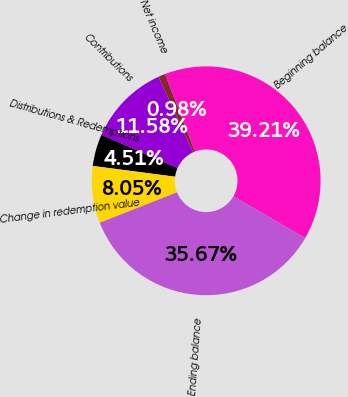Convert chart. <chart><loc_0><loc_0><loc_500><loc_500><pie_chart><fcel>Beginning balance<fcel>Net income<fcel>Contributions<fcel>Distributions & Redemptions<fcel>Change in redemption value<fcel>Ending balance<nl><fcel>39.21%<fcel>0.98%<fcel>11.58%<fcel>4.51%<fcel>8.05%<fcel>35.67%<nl></chart> 